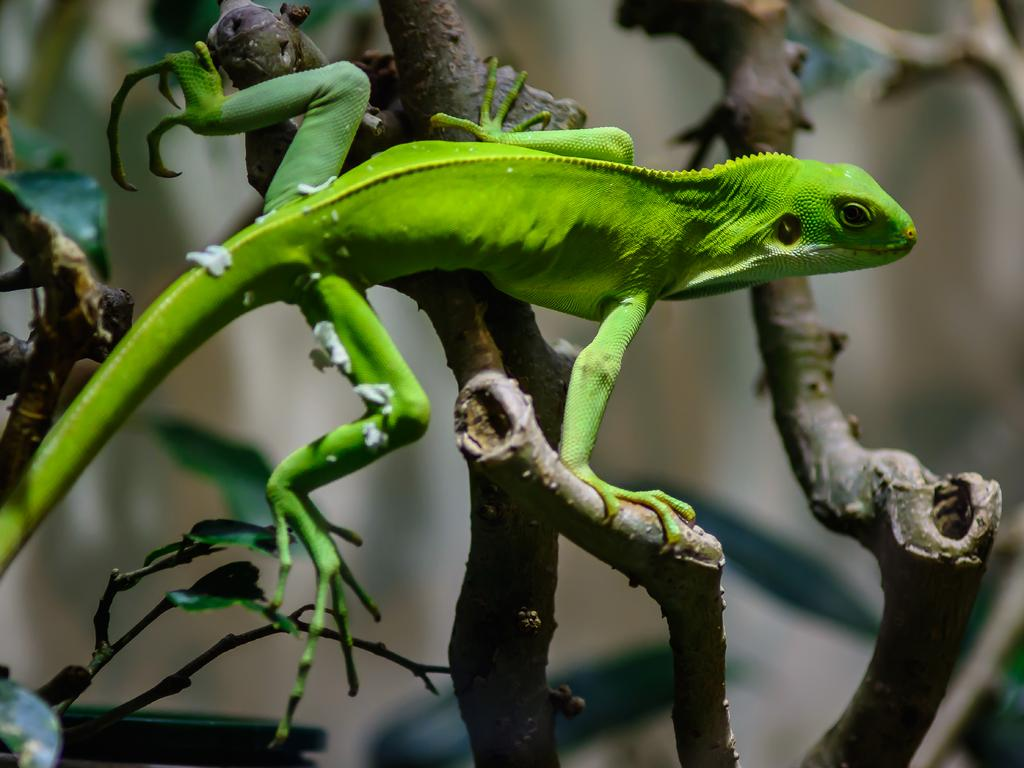What type of animal is in the picture? There is a reptile in the picture. What color is the reptile? The reptile is green in color. Where is the reptile located in the picture? The reptile is on the branches of a tree. What type of flesh can be seen hanging from the branches of the tree in the image? There is no flesh visible in the image; it features a green reptile on the branches of a tree. Can you tell me how many baseballs are present in the image? There are no baseballs present in the image. 